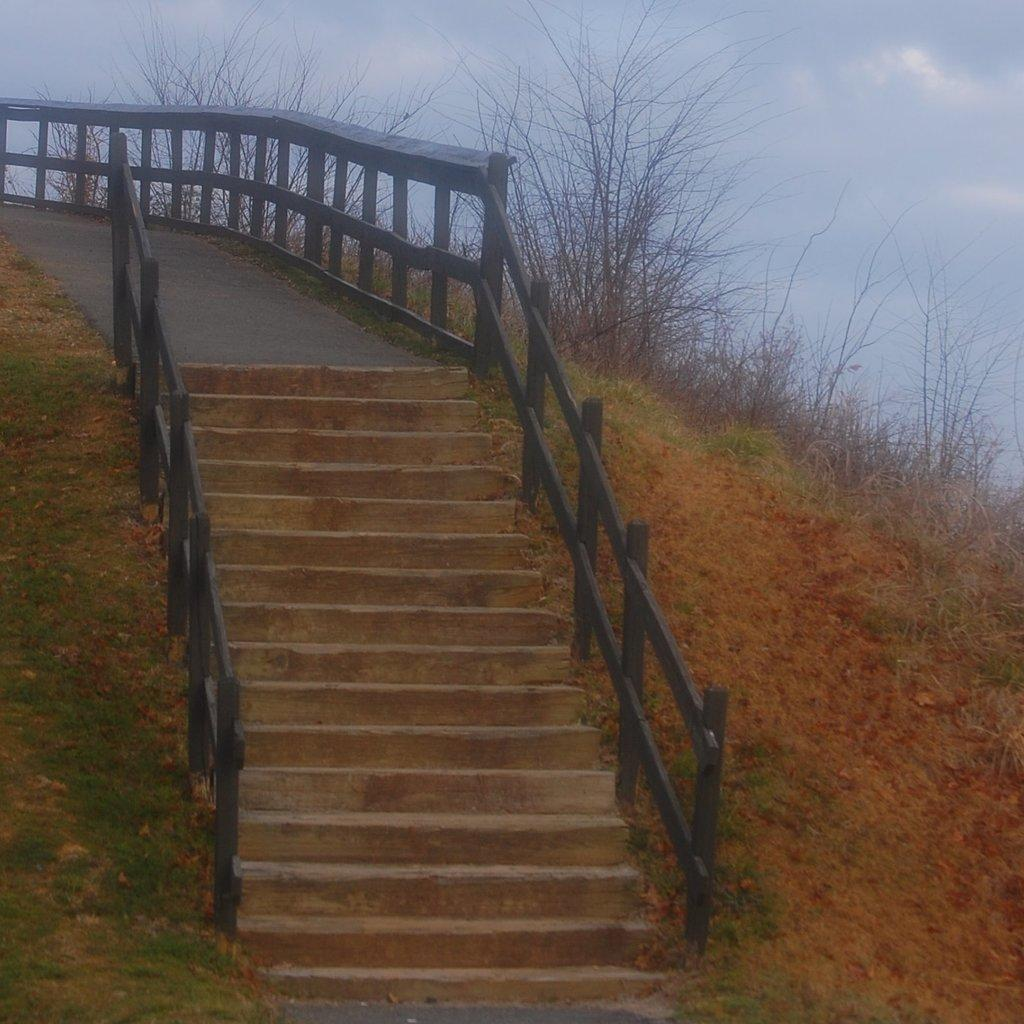What type of architectural feature is present in the image? There are steps in the image. What safety feature is present alongside the steps? There are railings in front of the steps. What type of natural environment is visible in the image? There is grass visible in the image. What type of vegetation is present in the image? There are plants in the image. What is visible in the background of the image? The sky is visible in the background of the image. How many rabbits can be seen hopping on the clover in the image? There are no rabbits or clover present in the image. 